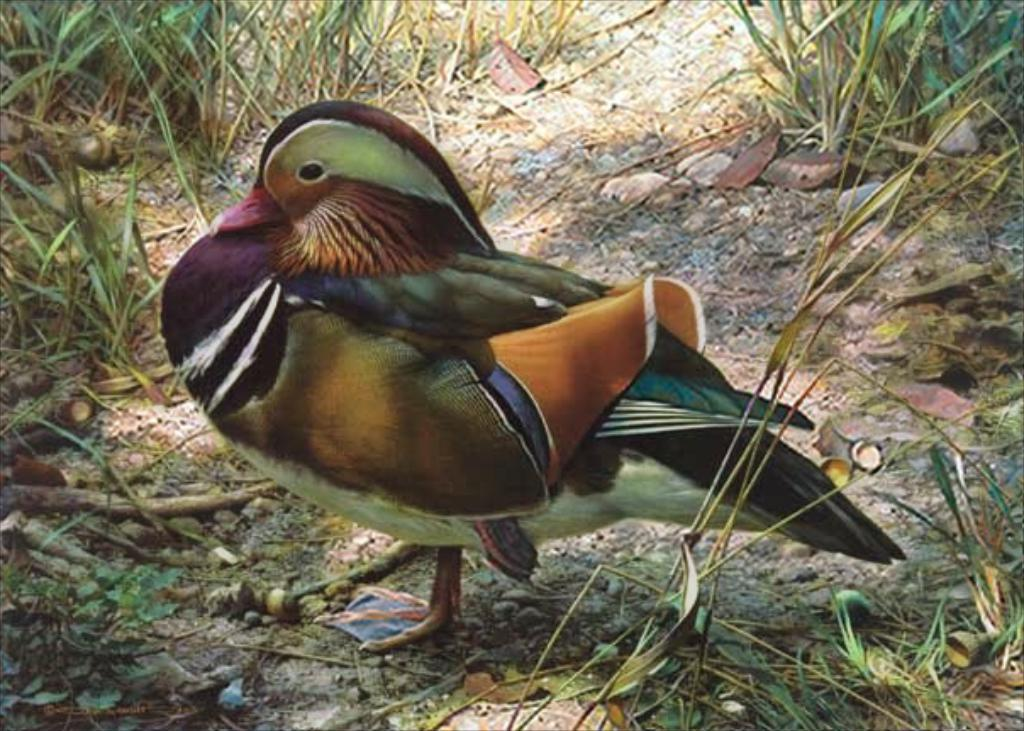What type of animal can be seen in the image? There is a bird in the image. What is the bird doing in the image? The bird is standing on the ground. What type of vegetation is visible in the image? There is a lot of grass in the image. What sense does the bird use to communicate with the ducks in the image? There are no ducks present in the image, and therefore no such communication can be observed. What type of material is the bird's leather jacket made of in the image? There is no indication of a leather jacket or any clothing on the bird in the image. 